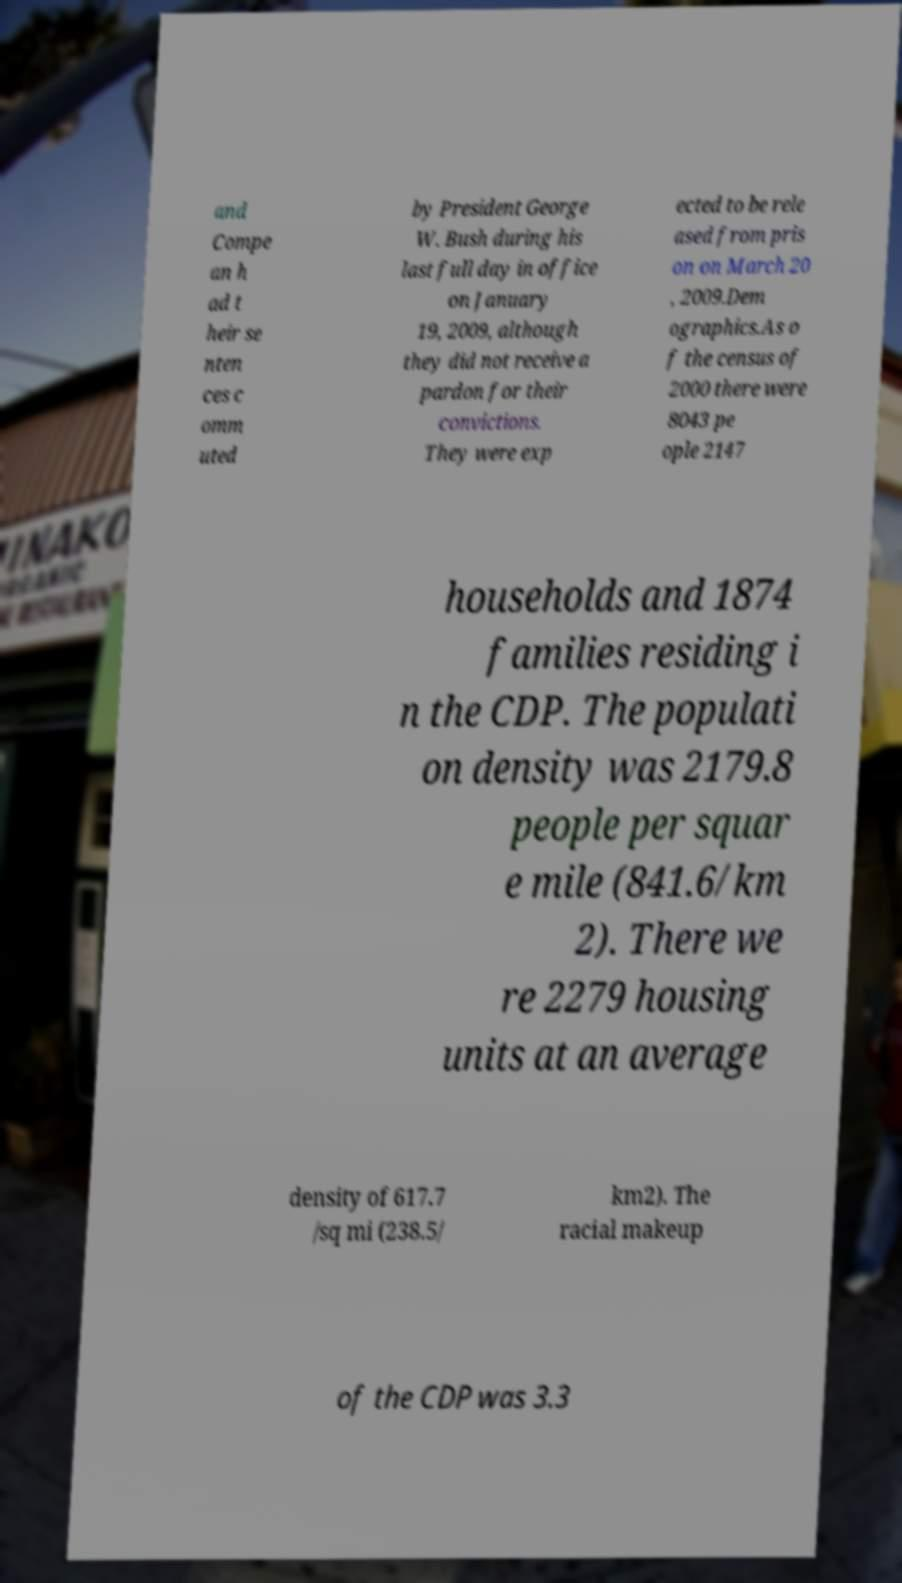Can you accurately transcribe the text from the provided image for me? and Compe an h ad t heir se nten ces c omm uted by President George W. Bush during his last full day in office on January 19, 2009, although they did not receive a pardon for their convictions. They were exp ected to be rele ased from pris on on March 20 , 2009.Dem ographics.As o f the census of 2000 there were 8043 pe ople 2147 households and 1874 families residing i n the CDP. The populati on density was 2179.8 people per squar e mile (841.6/km 2). There we re 2279 housing units at an average density of 617.7 /sq mi (238.5/ km2). The racial makeup of the CDP was 3.3 